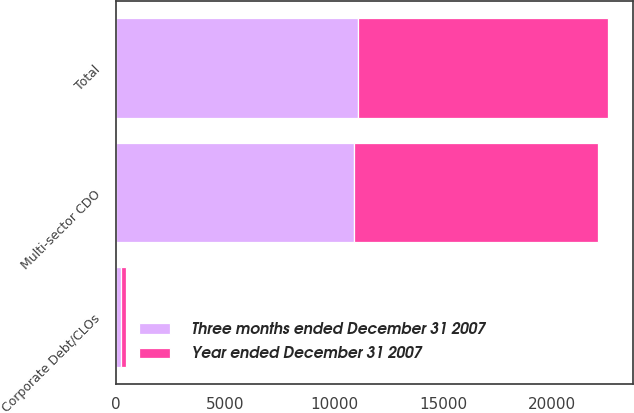<chart> <loc_0><loc_0><loc_500><loc_500><stacked_bar_chart><ecel><fcel>Multi-sector CDO<fcel>Corporate Debt/CLOs<fcel>Total<nl><fcel>Three months ended December 31 2007<fcel>10894<fcel>226<fcel>11120<nl><fcel>Year ended December 31 2007<fcel>11246<fcel>226<fcel>11472<nl></chart> 